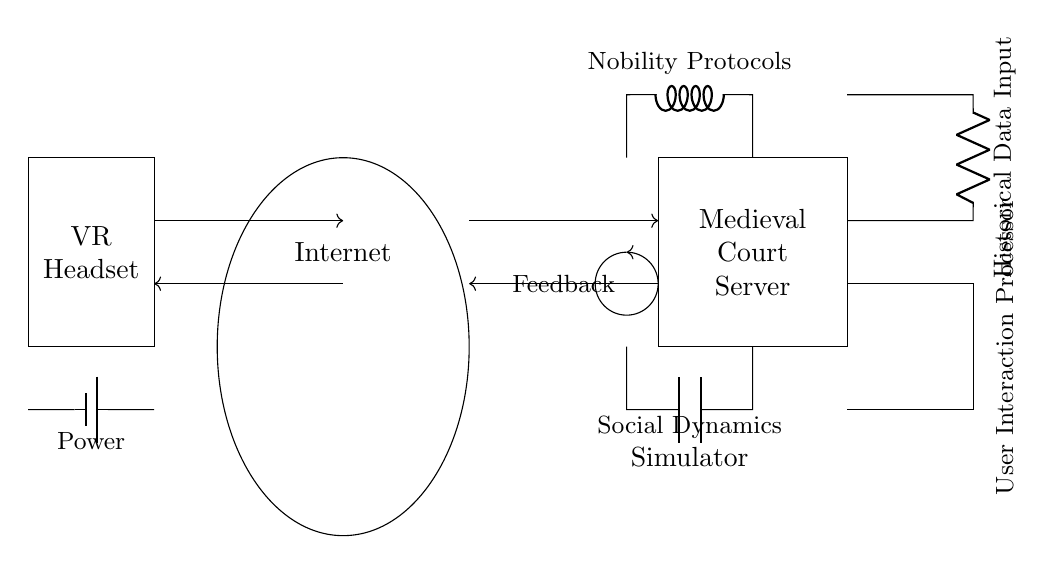What is the role of the power component in this circuit? The power component, represented as a battery, supplies the necessary electrical energy to operate the entire circuit, facilitating interaction between the components.
Answer: Power What type of connection is used between the VR headset and the medieval court server? The connection between the VR headset and the medieval court server is described as wireless, indicated by the presence of antennas.
Answer: Wireless What component simulates the feedback mechanism in the circuit? The feedback mechanism is represented by an arc that connects the social dynamics simulator back to the nobility protocols, allowing for iterative adjustments based on user interaction.
Answer: Feedback Which component processes user interactions? The user interaction processor is specifically designed to handle and process inputs from users engaging with the virtual reality experience.
Answer: User Interaction Processor What is the purpose of the nobility protocols in this circuit? The nobility protocols serve to govern the interactions and behaviors simulated in the medieval court, ensuring they align with historical social hierarchies and dynamics.
Answer: Nobility Protocols How does the historical data input affect the circuit's simulation? The historical data input enriches the simulation by supplying factual context, enhancing the authenticity of user experiences within the medieval court environment through accurate historical scenarios.
Answer: Historical Data Input 